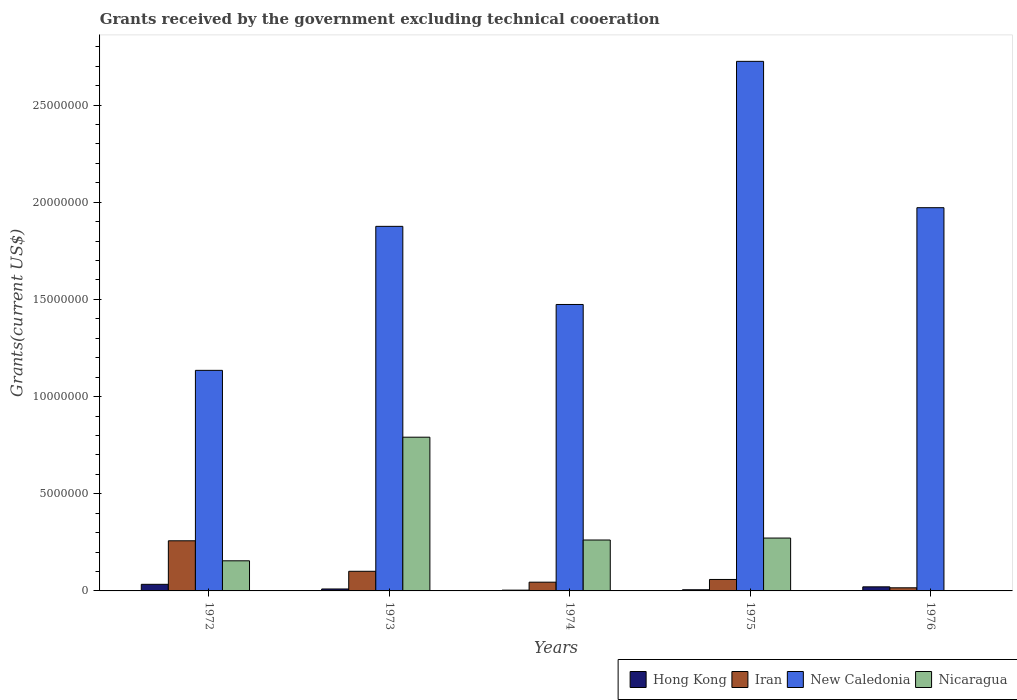Are the number of bars per tick equal to the number of legend labels?
Your response must be concise. No. How many bars are there on the 4th tick from the left?
Ensure brevity in your answer.  4. What is the label of the 5th group of bars from the left?
Keep it short and to the point. 1976. In how many cases, is the number of bars for a given year not equal to the number of legend labels?
Your answer should be very brief. 1. What is the total grants received by the government in New Caledonia in 1975?
Your answer should be very brief. 2.72e+07. Across all years, what is the maximum total grants received by the government in Nicaragua?
Your answer should be very brief. 7.91e+06. What is the total total grants received by the government in Nicaragua in the graph?
Provide a succinct answer. 1.48e+07. What is the difference between the total grants received by the government in Iran in 1972 and that in 1975?
Offer a very short reply. 1.99e+06. What is the difference between the total grants received by the government in Iran in 1975 and the total grants received by the government in New Caledonia in 1974?
Give a very brief answer. -1.42e+07. What is the average total grants received by the government in Hong Kong per year?
Your answer should be very brief. 1.50e+05. In the year 1976, what is the difference between the total grants received by the government in Iran and total grants received by the government in New Caledonia?
Your answer should be very brief. -1.96e+07. In how many years, is the total grants received by the government in Nicaragua greater than 9000000 US$?
Your answer should be compact. 0. What is the ratio of the total grants received by the government in Hong Kong in 1972 to that in 1973?
Provide a short and direct response. 3.4. Is the total grants received by the government in New Caledonia in 1973 less than that in 1976?
Offer a very short reply. Yes. What is the difference between the highest and the second highest total grants received by the government in Hong Kong?
Keep it short and to the point. 1.30e+05. What is the difference between the highest and the lowest total grants received by the government in Nicaragua?
Keep it short and to the point. 7.91e+06. In how many years, is the total grants received by the government in Iran greater than the average total grants received by the government in Iran taken over all years?
Make the answer very short. 2. Is it the case that in every year, the sum of the total grants received by the government in Hong Kong and total grants received by the government in Iran is greater than the sum of total grants received by the government in Nicaragua and total grants received by the government in New Caledonia?
Give a very brief answer. No. How many years are there in the graph?
Provide a short and direct response. 5. Are the values on the major ticks of Y-axis written in scientific E-notation?
Ensure brevity in your answer.  No. Does the graph contain any zero values?
Give a very brief answer. Yes. Does the graph contain grids?
Keep it short and to the point. No. Where does the legend appear in the graph?
Ensure brevity in your answer.  Bottom right. How many legend labels are there?
Provide a succinct answer. 4. How are the legend labels stacked?
Your response must be concise. Horizontal. What is the title of the graph?
Offer a very short reply. Grants received by the government excluding technical cooeration. Does "Myanmar" appear as one of the legend labels in the graph?
Offer a terse response. No. What is the label or title of the X-axis?
Your answer should be compact. Years. What is the label or title of the Y-axis?
Keep it short and to the point. Grants(current US$). What is the Grants(current US$) in Iran in 1972?
Provide a short and direct response. 2.58e+06. What is the Grants(current US$) in New Caledonia in 1972?
Ensure brevity in your answer.  1.14e+07. What is the Grants(current US$) of Nicaragua in 1972?
Provide a short and direct response. 1.55e+06. What is the Grants(current US$) in Hong Kong in 1973?
Your response must be concise. 1.00e+05. What is the Grants(current US$) of Iran in 1973?
Your response must be concise. 1.01e+06. What is the Grants(current US$) of New Caledonia in 1973?
Keep it short and to the point. 1.88e+07. What is the Grants(current US$) in Nicaragua in 1973?
Offer a very short reply. 7.91e+06. What is the Grants(current US$) of Iran in 1974?
Offer a very short reply. 4.50e+05. What is the Grants(current US$) in New Caledonia in 1974?
Your response must be concise. 1.47e+07. What is the Grants(current US$) of Nicaragua in 1974?
Provide a succinct answer. 2.62e+06. What is the Grants(current US$) of Hong Kong in 1975?
Keep it short and to the point. 6.00e+04. What is the Grants(current US$) of Iran in 1975?
Provide a succinct answer. 5.90e+05. What is the Grants(current US$) in New Caledonia in 1975?
Provide a short and direct response. 2.72e+07. What is the Grants(current US$) in Nicaragua in 1975?
Provide a succinct answer. 2.72e+06. What is the Grants(current US$) in New Caledonia in 1976?
Offer a terse response. 1.97e+07. What is the Grants(current US$) in Nicaragua in 1976?
Your answer should be compact. 0. Across all years, what is the maximum Grants(current US$) of Hong Kong?
Your answer should be compact. 3.40e+05. Across all years, what is the maximum Grants(current US$) of Iran?
Provide a short and direct response. 2.58e+06. Across all years, what is the maximum Grants(current US$) in New Caledonia?
Make the answer very short. 2.72e+07. Across all years, what is the maximum Grants(current US$) in Nicaragua?
Keep it short and to the point. 7.91e+06. Across all years, what is the minimum Grants(current US$) in Hong Kong?
Your response must be concise. 4.00e+04. Across all years, what is the minimum Grants(current US$) in Iran?
Offer a terse response. 1.60e+05. Across all years, what is the minimum Grants(current US$) of New Caledonia?
Ensure brevity in your answer.  1.14e+07. What is the total Grants(current US$) in Hong Kong in the graph?
Your answer should be compact. 7.50e+05. What is the total Grants(current US$) in Iran in the graph?
Give a very brief answer. 4.79e+06. What is the total Grants(current US$) of New Caledonia in the graph?
Ensure brevity in your answer.  9.18e+07. What is the total Grants(current US$) of Nicaragua in the graph?
Provide a short and direct response. 1.48e+07. What is the difference between the Grants(current US$) in Iran in 1972 and that in 1973?
Your answer should be compact. 1.57e+06. What is the difference between the Grants(current US$) in New Caledonia in 1972 and that in 1973?
Make the answer very short. -7.41e+06. What is the difference between the Grants(current US$) in Nicaragua in 1972 and that in 1973?
Provide a short and direct response. -6.36e+06. What is the difference between the Grants(current US$) in Iran in 1972 and that in 1974?
Provide a succinct answer. 2.13e+06. What is the difference between the Grants(current US$) of New Caledonia in 1972 and that in 1974?
Offer a terse response. -3.39e+06. What is the difference between the Grants(current US$) of Nicaragua in 1972 and that in 1974?
Make the answer very short. -1.07e+06. What is the difference between the Grants(current US$) in Hong Kong in 1972 and that in 1975?
Offer a very short reply. 2.80e+05. What is the difference between the Grants(current US$) in Iran in 1972 and that in 1975?
Offer a very short reply. 1.99e+06. What is the difference between the Grants(current US$) in New Caledonia in 1972 and that in 1975?
Keep it short and to the point. -1.59e+07. What is the difference between the Grants(current US$) in Nicaragua in 1972 and that in 1975?
Ensure brevity in your answer.  -1.17e+06. What is the difference between the Grants(current US$) of Iran in 1972 and that in 1976?
Ensure brevity in your answer.  2.42e+06. What is the difference between the Grants(current US$) of New Caledonia in 1972 and that in 1976?
Offer a very short reply. -8.37e+06. What is the difference between the Grants(current US$) in Hong Kong in 1973 and that in 1974?
Keep it short and to the point. 6.00e+04. What is the difference between the Grants(current US$) of Iran in 1973 and that in 1974?
Make the answer very short. 5.60e+05. What is the difference between the Grants(current US$) of New Caledonia in 1973 and that in 1974?
Keep it short and to the point. 4.02e+06. What is the difference between the Grants(current US$) in Nicaragua in 1973 and that in 1974?
Give a very brief answer. 5.29e+06. What is the difference between the Grants(current US$) of Iran in 1973 and that in 1975?
Offer a terse response. 4.20e+05. What is the difference between the Grants(current US$) of New Caledonia in 1973 and that in 1975?
Give a very brief answer. -8.49e+06. What is the difference between the Grants(current US$) in Nicaragua in 1973 and that in 1975?
Offer a terse response. 5.19e+06. What is the difference between the Grants(current US$) of Iran in 1973 and that in 1976?
Make the answer very short. 8.50e+05. What is the difference between the Grants(current US$) of New Caledonia in 1973 and that in 1976?
Your answer should be very brief. -9.60e+05. What is the difference between the Grants(current US$) in Hong Kong in 1974 and that in 1975?
Your response must be concise. -2.00e+04. What is the difference between the Grants(current US$) of New Caledonia in 1974 and that in 1975?
Your answer should be very brief. -1.25e+07. What is the difference between the Grants(current US$) in Hong Kong in 1974 and that in 1976?
Make the answer very short. -1.70e+05. What is the difference between the Grants(current US$) of New Caledonia in 1974 and that in 1976?
Your answer should be very brief. -4.98e+06. What is the difference between the Grants(current US$) of Hong Kong in 1975 and that in 1976?
Offer a very short reply. -1.50e+05. What is the difference between the Grants(current US$) of New Caledonia in 1975 and that in 1976?
Provide a short and direct response. 7.53e+06. What is the difference between the Grants(current US$) of Hong Kong in 1972 and the Grants(current US$) of Iran in 1973?
Keep it short and to the point. -6.70e+05. What is the difference between the Grants(current US$) of Hong Kong in 1972 and the Grants(current US$) of New Caledonia in 1973?
Provide a succinct answer. -1.84e+07. What is the difference between the Grants(current US$) in Hong Kong in 1972 and the Grants(current US$) in Nicaragua in 1973?
Make the answer very short. -7.57e+06. What is the difference between the Grants(current US$) in Iran in 1972 and the Grants(current US$) in New Caledonia in 1973?
Make the answer very short. -1.62e+07. What is the difference between the Grants(current US$) in Iran in 1972 and the Grants(current US$) in Nicaragua in 1973?
Offer a terse response. -5.33e+06. What is the difference between the Grants(current US$) in New Caledonia in 1972 and the Grants(current US$) in Nicaragua in 1973?
Provide a succinct answer. 3.44e+06. What is the difference between the Grants(current US$) in Hong Kong in 1972 and the Grants(current US$) in Iran in 1974?
Ensure brevity in your answer.  -1.10e+05. What is the difference between the Grants(current US$) of Hong Kong in 1972 and the Grants(current US$) of New Caledonia in 1974?
Provide a succinct answer. -1.44e+07. What is the difference between the Grants(current US$) in Hong Kong in 1972 and the Grants(current US$) in Nicaragua in 1974?
Your response must be concise. -2.28e+06. What is the difference between the Grants(current US$) of Iran in 1972 and the Grants(current US$) of New Caledonia in 1974?
Provide a succinct answer. -1.22e+07. What is the difference between the Grants(current US$) in New Caledonia in 1972 and the Grants(current US$) in Nicaragua in 1974?
Provide a short and direct response. 8.73e+06. What is the difference between the Grants(current US$) of Hong Kong in 1972 and the Grants(current US$) of New Caledonia in 1975?
Offer a terse response. -2.69e+07. What is the difference between the Grants(current US$) in Hong Kong in 1972 and the Grants(current US$) in Nicaragua in 1975?
Your answer should be very brief. -2.38e+06. What is the difference between the Grants(current US$) in Iran in 1972 and the Grants(current US$) in New Caledonia in 1975?
Provide a succinct answer. -2.47e+07. What is the difference between the Grants(current US$) of Iran in 1972 and the Grants(current US$) of Nicaragua in 1975?
Offer a terse response. -1.40e+05. What is the difference between the Grants(current US$) of New Caledonia in 1972 and the Grants(current US$) of Nicaragua in 1975?
Your response must be concise. 8.63e+06. What is the difference between the Grants(current US$) of Hong Kong in 1972 and the Grants(current US$) of New Caledonia in 1976?
Give a very brief answer. -1.94e+07. What is the difference between the Grants(current US$) of Iran in 1972 and the Grants(current US$) of New Caledonia in 1976?
Ensure brevity in your answer.  -1.71e+07. What is the difference between the Grants(current US$) of Hong Kong in 1973 and the Grants(current US$) of Iran in 1974?
Your answer should be very brief. -3.50e+05. What is the difference between the Grants(current US$) in Hong Kong in 1973 and the Grants(current US$) in New Caledonia in 1974?
Ensure brevity in your answer.  -1.46e+07. What is the difference between the Grants(current US$) of Hong Kong in 1973 and the Grants(current US$) of Nicaragua in 1974?
Make the answer very short. -2.52e+06. What is the difference between the Grants(current US$) in Iran in 1973 and the Grants(current US$) in New Caledonia in 1974?
Give a very brief answer. -1.37e+07. What is the difference between the Grants(current US$) in Iran in 1973 and the Grants(current US$) in Nicaragua in 1974?
Ensure brevity in your answer.  -1.61e+06. What is the difference between the Grants(current US$) of New Caledonia in 1973 and the Grants(current US$) of Nicaragua in 1974?
Provide a succinct answer. 1.61e+07. What is the difference between the Grants(current US$) in Hong Kong in 1973 and the Grants(current US$) in Iran in 1975?
Offer a terse response. -4.90e+05. What is the difference between the Grants(current US$) of Hong Kong in 1973 and the Grants(current US$) of New Caledonia in 1975?
Offer a very short reply. -2.72e+07. What is the difference between the Grants(current US$) in Hong Kong in 1973 and the Grants(current US$) in Nicaragua in 1975?
Offer a terse response. -2.62e+06. What is the difference between the Grants(current US$) of Iran in 1973 and the Grants(current US$) of New Caledonia in 1975?
Make the answer very short. -2.62e+07. What is the difference between the Grants(current US$) of Iran in 1973 and the Grants(current US$) of Nicaragua in 1975?
Ensure brevity in your answer.  -1.71e+06. What is the difference between the Grants(current US$) of New Caledonia in 1973 and the Grants(current US$) of Nicaragua in 1975?
Ensure brevity in your answer.  1.60e+07. What is the difference between the Grants(current US$) of Hong Kong in 1973 and the Grants(current US$) of New Caledonia in 1976?
Provide a succinct answer. -1.96e+07. What is the difference between the Grants(current US$) of Iran in 1973 and the Grants(current US$) of New Caledonia in 1976?
Ensure brevity in your answer.  -1.87e+07. What is the difference between the Grants(current US$) of Hong Kong in 1974 and the Grants(current US$) of Iran in 1975?
Ensure brevity in your answer.  -5.50e+05. What is the difference between the Grants(current US$) in Hong Kong in 1974 and the Grants(current US$) in New Caledonia in 1975?
Keep it short and to the point. -2.72e+07. What is the difference between the Grants(current US$) of Hong Kong in 1974 and the Grants(current US$) of Nicaragua in 1975?
Give a very brief answer. -2.68e+06. What is the difference between the Grants(current US$) in Iran in 1974 and the Grants(current US$) in New Caledonia in 1975?
Offer a terse response. -2.68e+07. What is the difference between the Grants(current US$) of Iran in 1974 and the Grants(current US$) of Nicaragua in 1975?
Provide a short and direct response. -2.27e+06. What is the difference between the Grants(current US$) of New Caledonia in 1974 and the Grants(current US$) of Nicaragua in 1975?
Ensure brevity in your answer.  1.20e+07. What is the difference between the Grants(current US$) of Hong Kong in 1974 and the Grants(current US$) of Iran in 1976?
Provide a short and direct response. -1.20e+05. What is the difference between the Grants(current US$) in Hong Kong in 1974 and the Grants(current US$) in New Caledonia in 1976?
Provide a succinct answer. -1.97e+07. What is the difference between the Grants(current US$) of Iran in 1974 and the Grants(current US$) of New Caledonia in 1976?
Make the answer very short. -1.93e+07. What is the difference between the Grants(current US$) of Hong Kong in 1975 and the Grants(current US$) of Iran in 1976?
Offer a terse response. -1.00e+05. What is the difference between the Grants(current US$) of Hong Kong in 1975 and the Grants(current US$) of New Caledonia in 1976?
Offer a very short reply. -1.97e+07. What is the difference between the Grants(current US$) in Iran in 1975 and the Grants(current US$) in New Caledonia in 1976?
Ensure brevity in your answer.  -1.91e+07. What is the average Grants(current US$) in Hong Kong per year?
Your response must be concise. 1.50e+05. What is the average Grants(current US$) of Iran per year?
Your response must be concise. 9.58e+05. What is the average Grants(current US$) in New Caledonia per year?
Your answer should be very brief. 1.84e+07. What is the average Grants(current US$) of Nicaragua per year?
Keep it short and to the point. 2.96e+06. In the year 1972, what is the difference between the Grants(current US$) of Hong Kong and Grants(current US$) of Iran?
Offer a terse response. -2.24e+06. In the year 1972, what is the difference between the Grants(current US$) of Hong Kong and Grants(current US$) of New Caledonia?
Ensure brevity in your answer.  -1.10e+07. In the year 1972, what is the difference between the Grants(current US$) in Hong Kong and Grants(current US$) in Nicaragua?
Provide a short and direct response. -1.21e+06. In the year 1972, what is the difference between the Grants(current US$) in Iran and Grants(current US$) in New Caledonia?
Provide a short and direct response. -8.77e+06. In the year 1972, what is the difference between the Grants(current US$) of Iran and Grants(current US$) of Nicaragua?
Make the answer very short. 1.03e+06. In the year 1972, what is the difference between the Grants(current US$) in New Caledonia and Grants(current US$) in Nicaragua?
Give a very brief answer. 9.80e+06. In the year 1973, what is the difference between the Grants(current US$) in Hong Kong and Grants(current US$) in Iran?
Make the answer very short. -9.10e+05. In the year 1973, what is the difference between the Grants(current US$) of Hong Kong and Grants(current US$) of New Caledonia?
Provide a succinct answer. -1.87e+07. In the year 1973, what is the difference between the Grants(current US$) of Hong Kong and Grants(current US$) of Nicaragua?
Give a very brief answer. -7.81e+06. In the year 1973, what is the difference between the Grants(current US$) in Iran and Grants(current US$) in New Caledonia?
Your response must be concise. -1.78e+07. In the year 1973, what is the difference between the Grants(current US$) in Iran and Grants(current US$) in Nicaragua?
Your answer should be compact. -6.90e+06. In the year 1973, what is the difference between the Grants(current US$) in New Caledonia and Grants(current US$) in Nicaragua?
Your answer should be very brief. 1.08e+07. In the year 1974, what is the difference between the Grants(current US$) of Hong Kong and Grants(current US$) of Iran?
Provide a short and direct response. -4.10e+05. In the year 1974, what is the difference between the Grants(current US$) in Hong Kong and Grants(current US$) in New Caledonia?
Keep it short and to the point. -1.47e+07. In the year 1974, what is the difference between the Grants(current US$) of Hong Kong and Grants(current US$) of Nicaragua?
Your answer should be very brief. -2.58e+06. In the year 1974, what is the difference between the Grants(current US$) of Iran and Grants(current US$) of New Caledonia?
Ensure brevity in your answer.  -1.43e+07. In the year 1974, what is the difference between the Grants(current US$) of Iran and Grants(current US$) of Nicaragua?
Make the answer very short. -2.17e+06. In the year 1974, what is the difference between the Grants(current US$) in New Caledonia and Grants(current US$) in Nicaragua?
Give a very brief answer. 1.21e+07. In the year 1975, what is the difference between the Grants(current US$) of Hong Kong and Grants(current US$) of Iran?
Provide a succinct answer. -5.30e+05. In the year 1975, what is the difference between the Grants(current US$) of Hong Kong and Grants(current US$) of New Caledonia?
Provide a short and direct response. -2.72e+07. In the year 1975, what is the difference between the Grants(current US$) in Hong Kong and Grants(current US$) in Nicaragua?
Provide a short and direct response. -2.66e+06. In the year 1975, what is the difference between the Grants(current US$) of Iran and Grants(current US$) of New Caledonia?
Provide a succinct answer. -2.67e+07. In the year 1975, what is the difference between the Grants(current US$) of Iran and Grants(current US$) of Nicaragua?
Offer a very short reply. -2.13e+06. In the year 1975, what is the difference between the Grants(current US$) in New Caledonia and Grants(current US$) in Nicaragua?
Make the answer very short. 2.45e+07. In the year 1976, what is the difference between the Grants(current US$) of Hong Kong and Grants(current US$) of New Caledonia?
Your response must be concise. -1.95e+07. In the year 1976, what is the difference between the Grants(current US$) in Iran and Grants(current US$) in New Caledonia?
Your response must be concise. -1.96e+07. What is the ratio of the Grants(current US$) in Iran in 1972 to that in 1973?
Keep it short and to the point. 2.55. What is the ratio of the Grants(current US$) of New Caledonia in 1972 to that in 1973?
Offer a terse response. 0.6. What is the ratio of the Grants(current US$) of Nicaragua in 1972 to that in 1973?
Keep it short and to the point. 0.2. What is the ratio of the Grants(current US$) of Iran in 1972 to that in 1974?
Keep it short and to the point. 5.73. What is the ratio of the Grants(current US$) in New Caledonia in 1972 to that in 1974?
Provide a short and direct response. 0.77. What is the ratio of the Grants(current US$) in Nicaragua in 1972 to that in 1974?
Your response must be concise. 0.59. What is the ratio of the Grants(current US$) of Hong Kong in 1972 to that in 1975?
Give a very brief answer. 5.67. What is the ratio of the Grants(current US$) of Iran in 1972 to that in 1975?
Provide a short and direct response. 4.37. What is the ratio of the Grants(current US$) of New Caledonia in 1972 to that in 1975?
Offer a terse response. 0.42. What is the ratio of the Grants(current US$) in Nicaragua in 1972 to that in 1975?
Your answer should be compact. 0.57. What is the ratio of the Grants(current US$) of Hong Kong in 1972 to that in 1976?
Your answer should be compact. 1.62. What is the ratio of the Grants(current US$) in Iran in 1972 to that in 1976?
Offer a terse response. 16.12. What is the ratio of the Grants(current US$) in New Caledonia in 1972 to that in 1976?
Your answer should be very brief. 0.58. What is the ratio of the Grants(current US$) in Hong Kong in 1973 to that in 1974?
Your response must be concise. 2.5. What is the ratio of the Grants(current US$) of Iran in 1973 to that in 1974?
Offer a very short reply. 2.24. What is the ratio of the Grants(current US$) in New Caledonia in 1973 to that in 1974?
Your answer should be compact. 1.27. What is the ratio of the Grants(current US$) in Nicaragua in 1973 to that in 1974?
Your answer should be compact. 3.02. What is the ratio of the Grants(current US$) of Iran in 1973 to that in 1975?
Ensure brevity in your answer.  1.71. What is the ratio of the Grants(current US$) of New Caledonia in 1973 to that in 1975?
Make the answer very short. 0.69. What is the ratio of the Grants(current US$) of Nicaragua in 1973 to that in 1975?
Give a very brief answer. 2.91. What is the ratio of the Grants(current US$) of Hong Kong in 1973 to that in 1976?
Keep it short and to the point. 0.48. What is the ratio of the Grants(current US$) in Iran in 1973 to that in 1976?
Ensure brevity in your answer.  6.31. What is the ratio of the Grants(current US$) of New Caledonia in 1973 to that in 1976?
Your answer should be compact. 0.95. What is the ratio of the Grants(current US$) of Hong Kong in 1974 to that in 1975?
Keep it short and to the point. 0.67. What is the ratio of the Grants(current US$) of Iran in 1974 to that in 1975?
Your answer should be compact. 0.76. What is the ratio of the Grants(current US$) of New Caledonia in 1974 to that in 1975?
Make the answer very short. 0.54. What is the ratio of the Grants(current US$) of Nicaragua in 1974 to that in 1975?
Your response must be concise. 0.96. What is the ratio of the Grants(current US$) in Hong Kong in 1974 to that in 1976?
Your answer should be compact. 0.19. What is the ratio of the Grants(current US$) in Iran in 1974 to that in 1976?
Give a very brief answer. 2.81. What is the ratio of the Grants(current US$) in New Caledonia in 1974 to that in 1976?
Provide a short and direct response. 0.75. What is the ratio of the Grants(current US$) of Hong Kong in 1975 to that in 1976?
Provide a succinct answer. 0.29. What is the ratio of the Grants(current US$) in Iran in 1975 to that in 1976?
Give a very brief answer. 3.69. What is the ratio of the Grants(current US$) of New Caledonia in 1975 to that in 1976?
Ensure brevity in your answer.  1.38. What is the difference between the highest and the second highest Grants(current US$) of Iran?
Give a very brief answer. 1.57e+06. What is the difference between the highest and the second highest Grants(current US$) in New Caledonia?
Provide a succinct answer. 7.53e+06. What is the difference between the highest and the second highest Grants(current US$) of Nicaragua?
Ensure brevity in your answer.  5.19e+06. What is the difference between the highest and the lowest Grants(current US$) in Hong Kong?
Ensure brevity in your answer.  3.00e+05. What is the difference between the highest and the lowest Grants(current US$) in Iran?
Offer a very short reply. 2.42e+06. What is the difference between the highest and the lowest Grants(current US$) in New Caledonia?
Provide a short and direct response. 1.59e+07. What is the difference between the highest and the lowest Grants(current US$) of Nicaragua?
Your answer should be compact. 7.91e+06. 